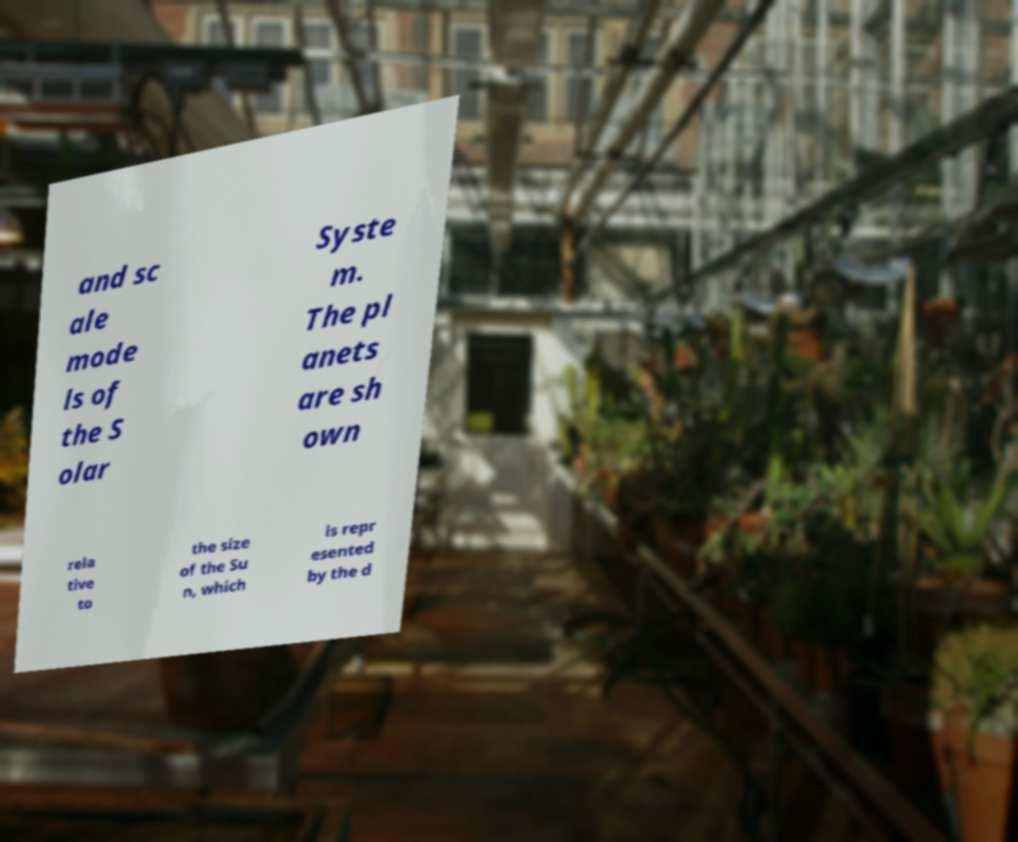Please read and relay the text visible in this image. What does it say? and sc ale mode ls of the S olar Syste m. The pl anets are sh own rela tive to the size of the Su n, which is repr esented by the d 